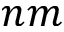<formula> <loc_0><loc_0><loc_500><loc_500>n m</formula> 